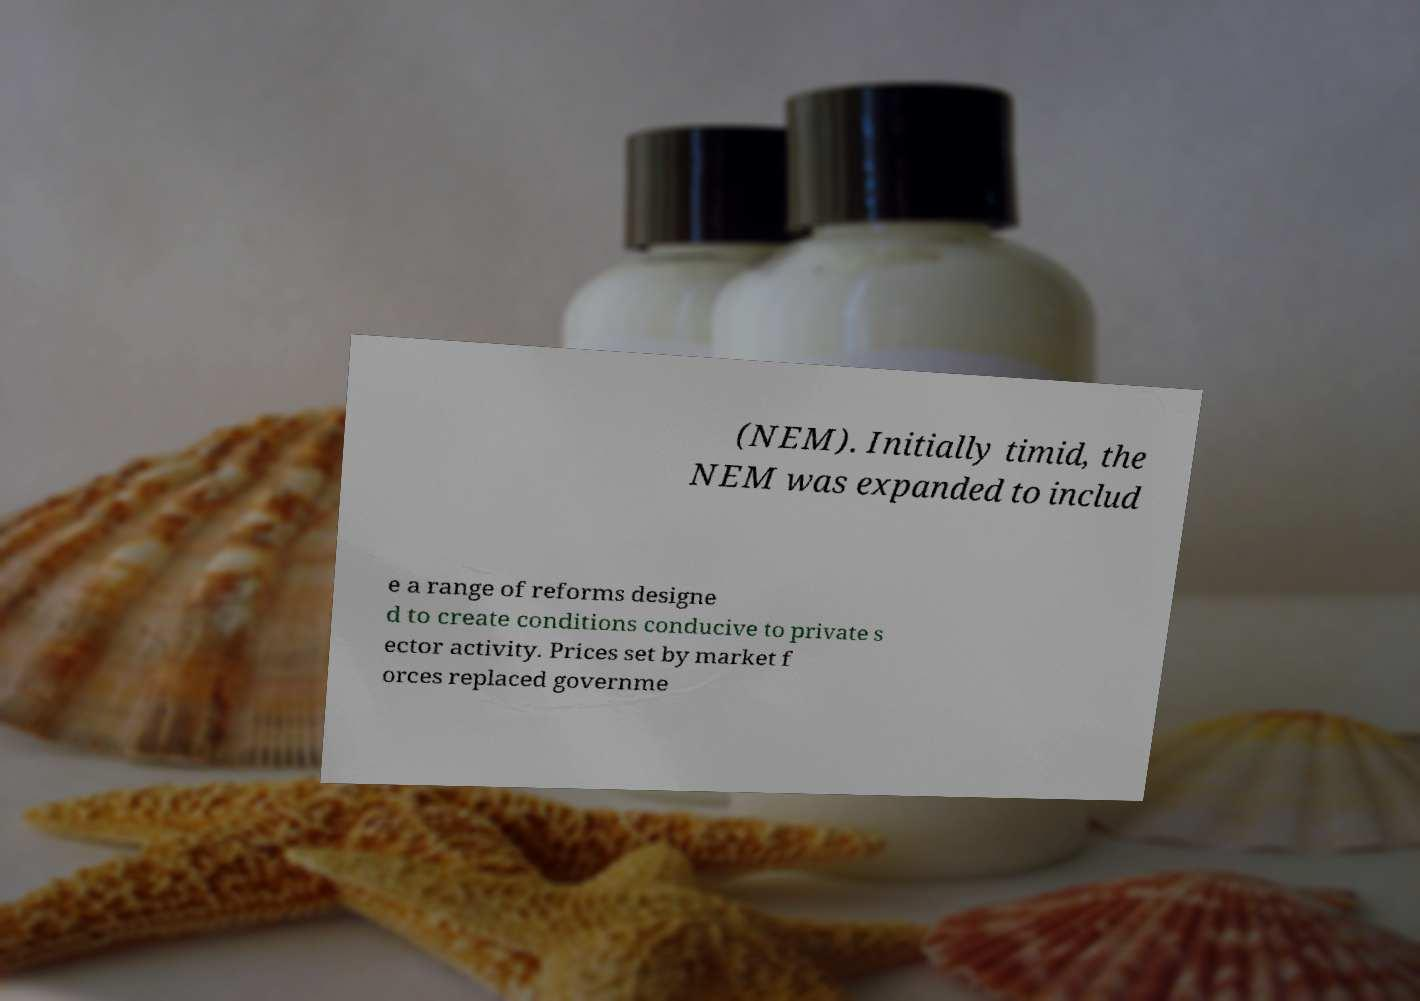What messages or text are displayed in this image? I need them in a readable, typed format. (NEM). Initially timid, the NEM was expanded to includ e a range of reforms designe d to create conditions conducive to private s ector activity. Prices set by market f orces replaced governme 